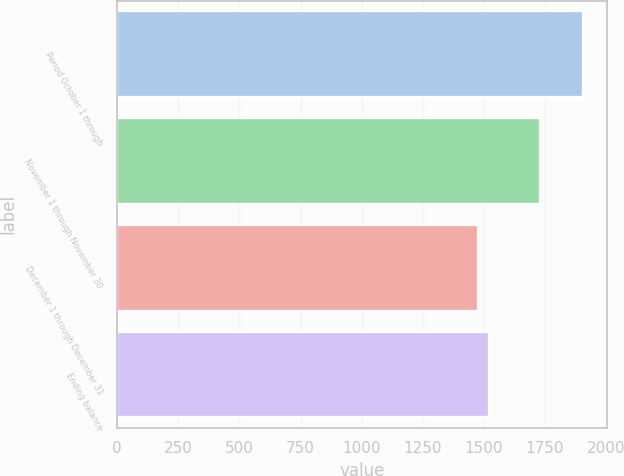Convert chart to OTSL. <chart><loc_0><loc_0><loc_500><loc_500><bar_chart><fcel>Period October 1 through<fcel>November 1 through November 30<fcel>December 1 through December 31<fcel>Ending balance<nl><fcel>1907<fcel>1728<fcel>1476<fcel>1519.1<nl></chart> 